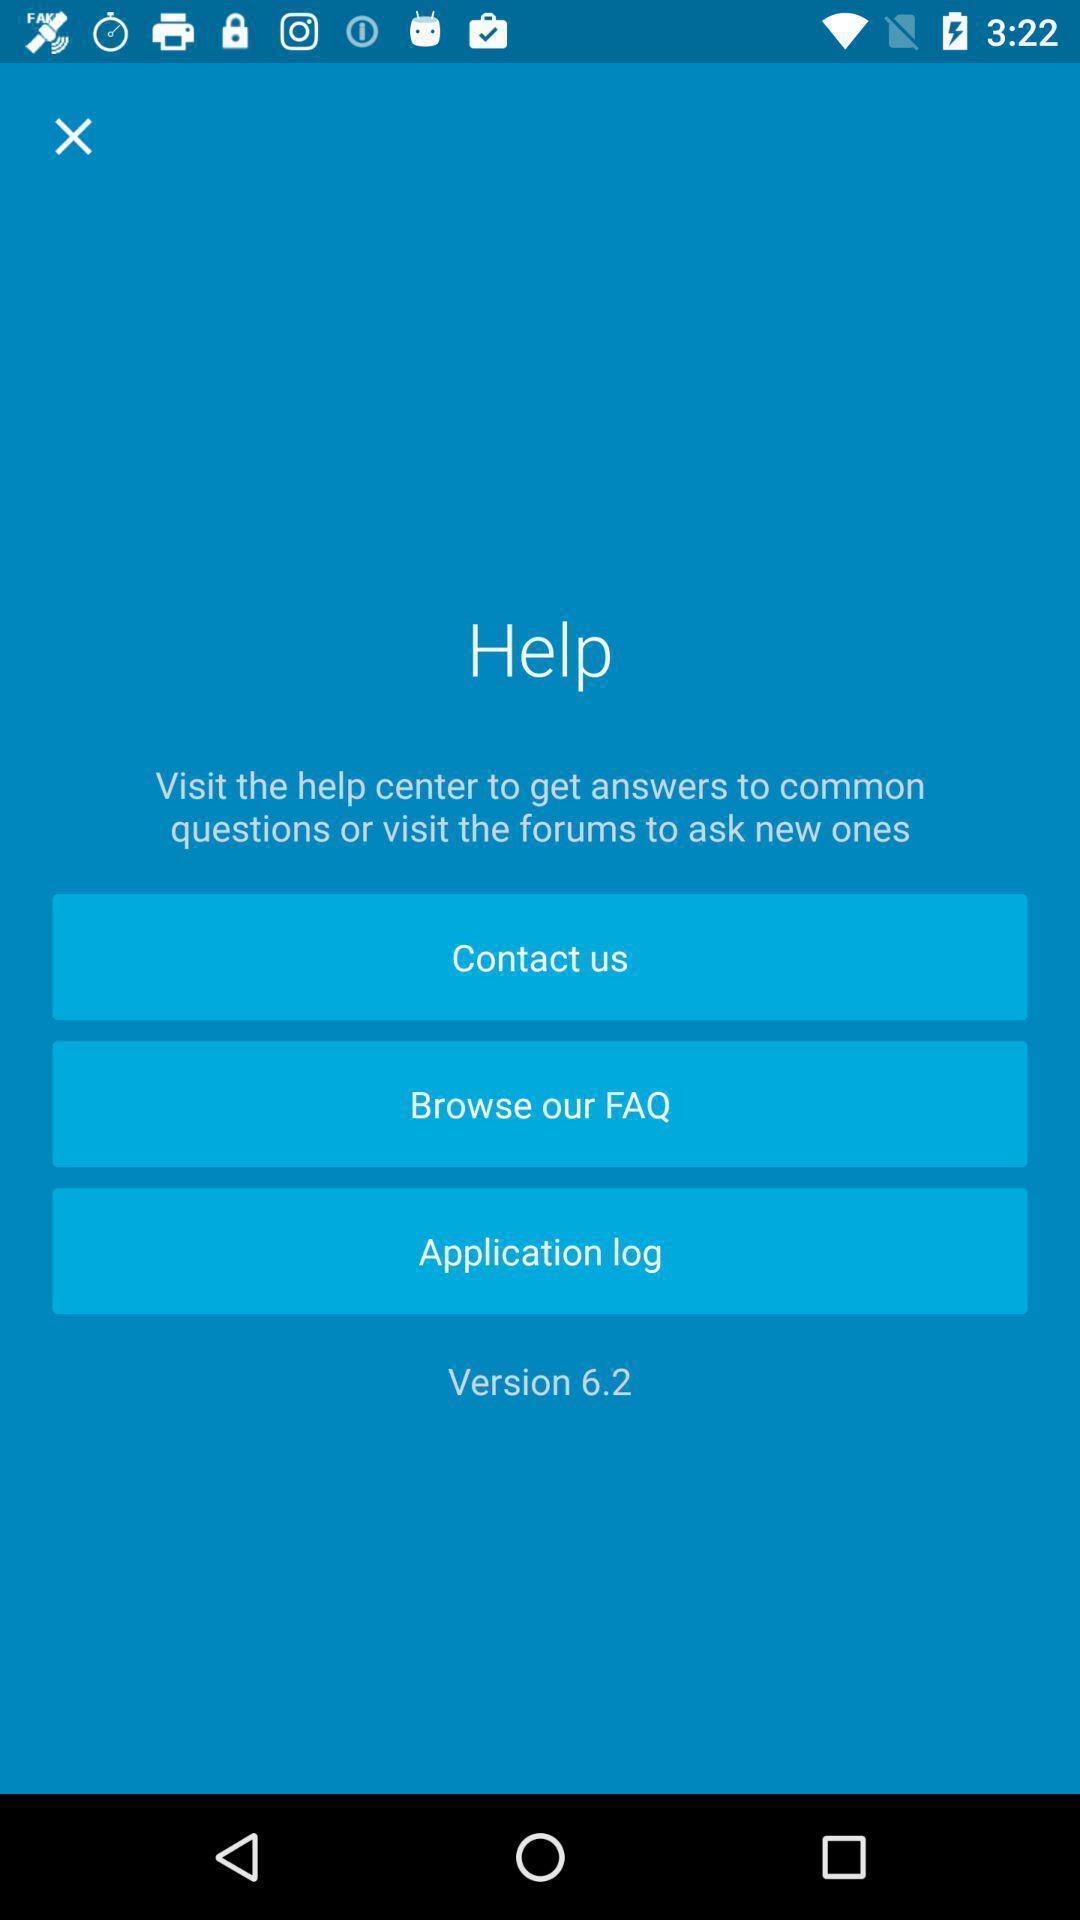What is the overall content of this screenshot? Screen presenting the help page with multiple options. 